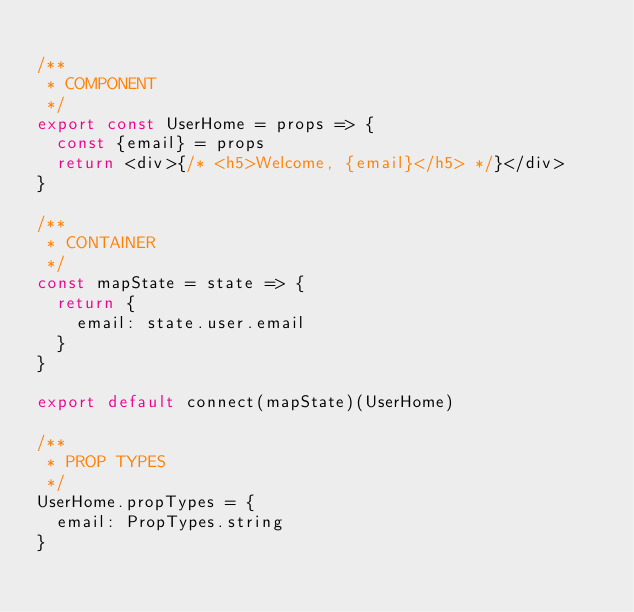<code> <loc_0><loc_0><loc_500><loc_500><_JavaScript_>
/**
 * COMPONENT
 */
export const UserHome = props => {
  const {email} = props
  return <div>{/* <h5>Welcome, {email}</h5> */}</div>
}

/**
 * CONTAINER
 */
const mapState = state => {
  return {
    email: state.user.email
  }
}

export default connect(mapState)(UserHome)

/**
 * PROP TYPES
 */
UserHome.propTypes = {
  email: PropTypes.string
}
</code> 